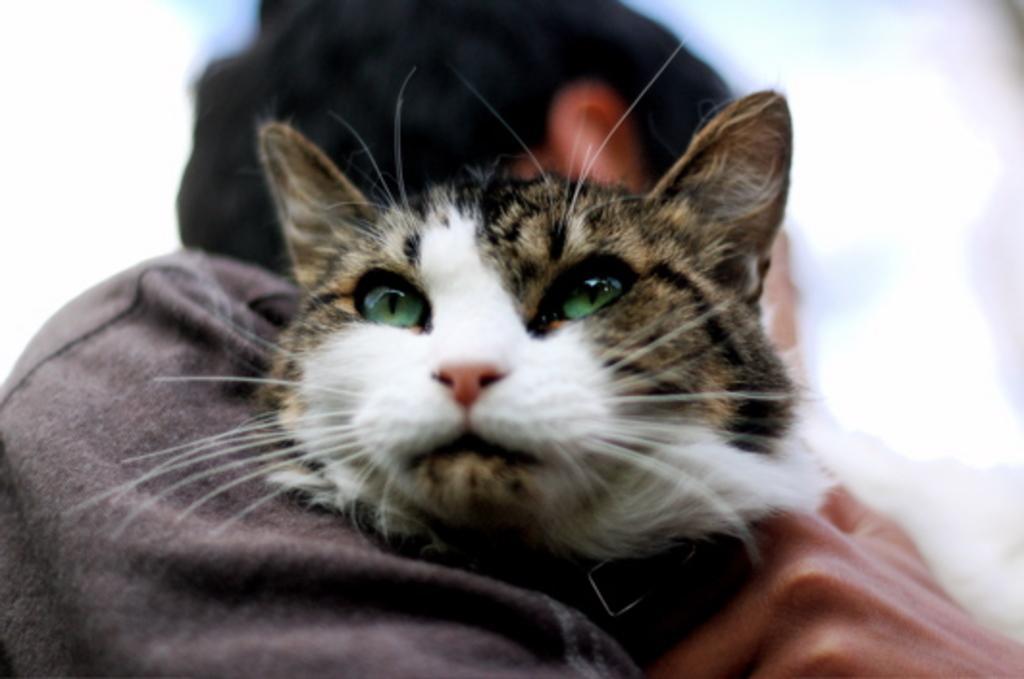Please provide a concise description of this image. In this image we can see there is a person holding a cat. And at the back there is a white background. 